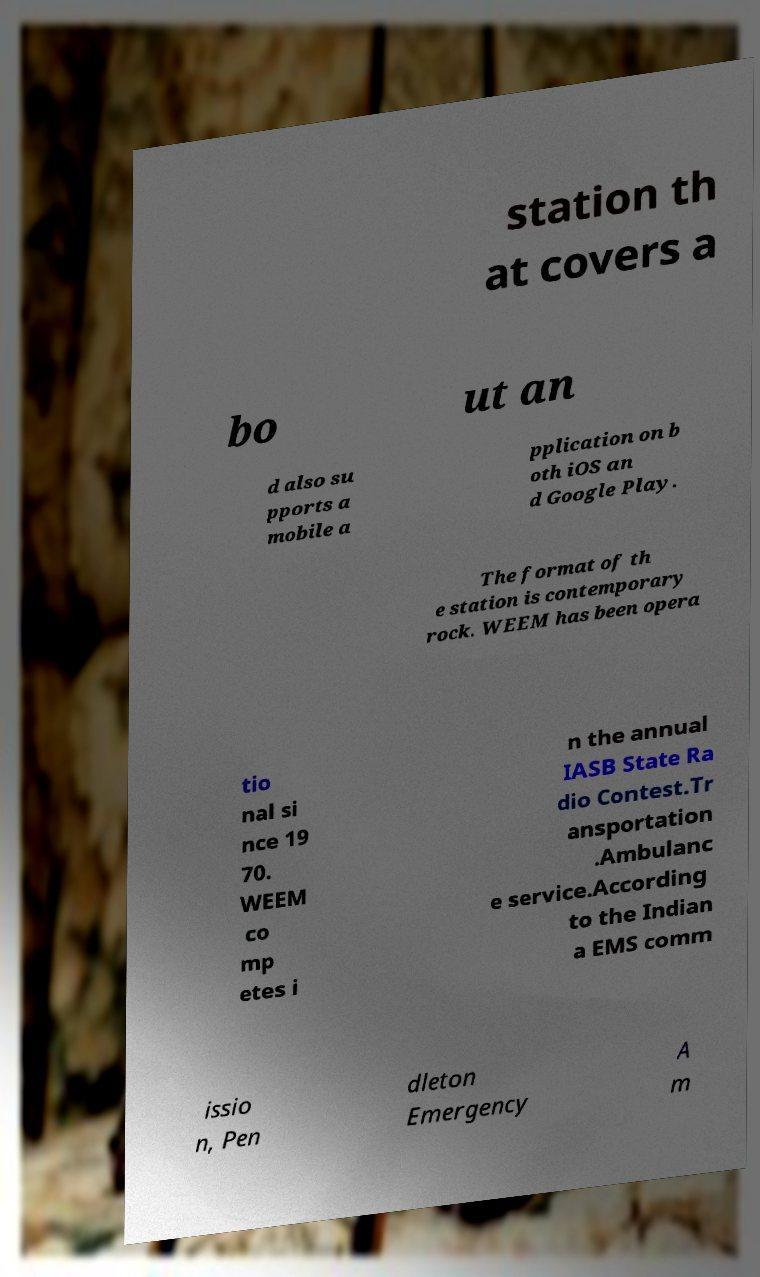Please identify and transcribe the text found in this image. station th at covers a bo ut an d also su pports a mobile a pplication on b oth iOS an d Google Play. The format of th e station is contemporary rock. WEEM has been opera tio nal si nce 19 70. WEEM co mp etes i n the annual IASB State Ra dio Contest.Tr ansportation .Ambulanc e service.According to the Indian a EMS comm issio n, Pen dleton Emergency A m 